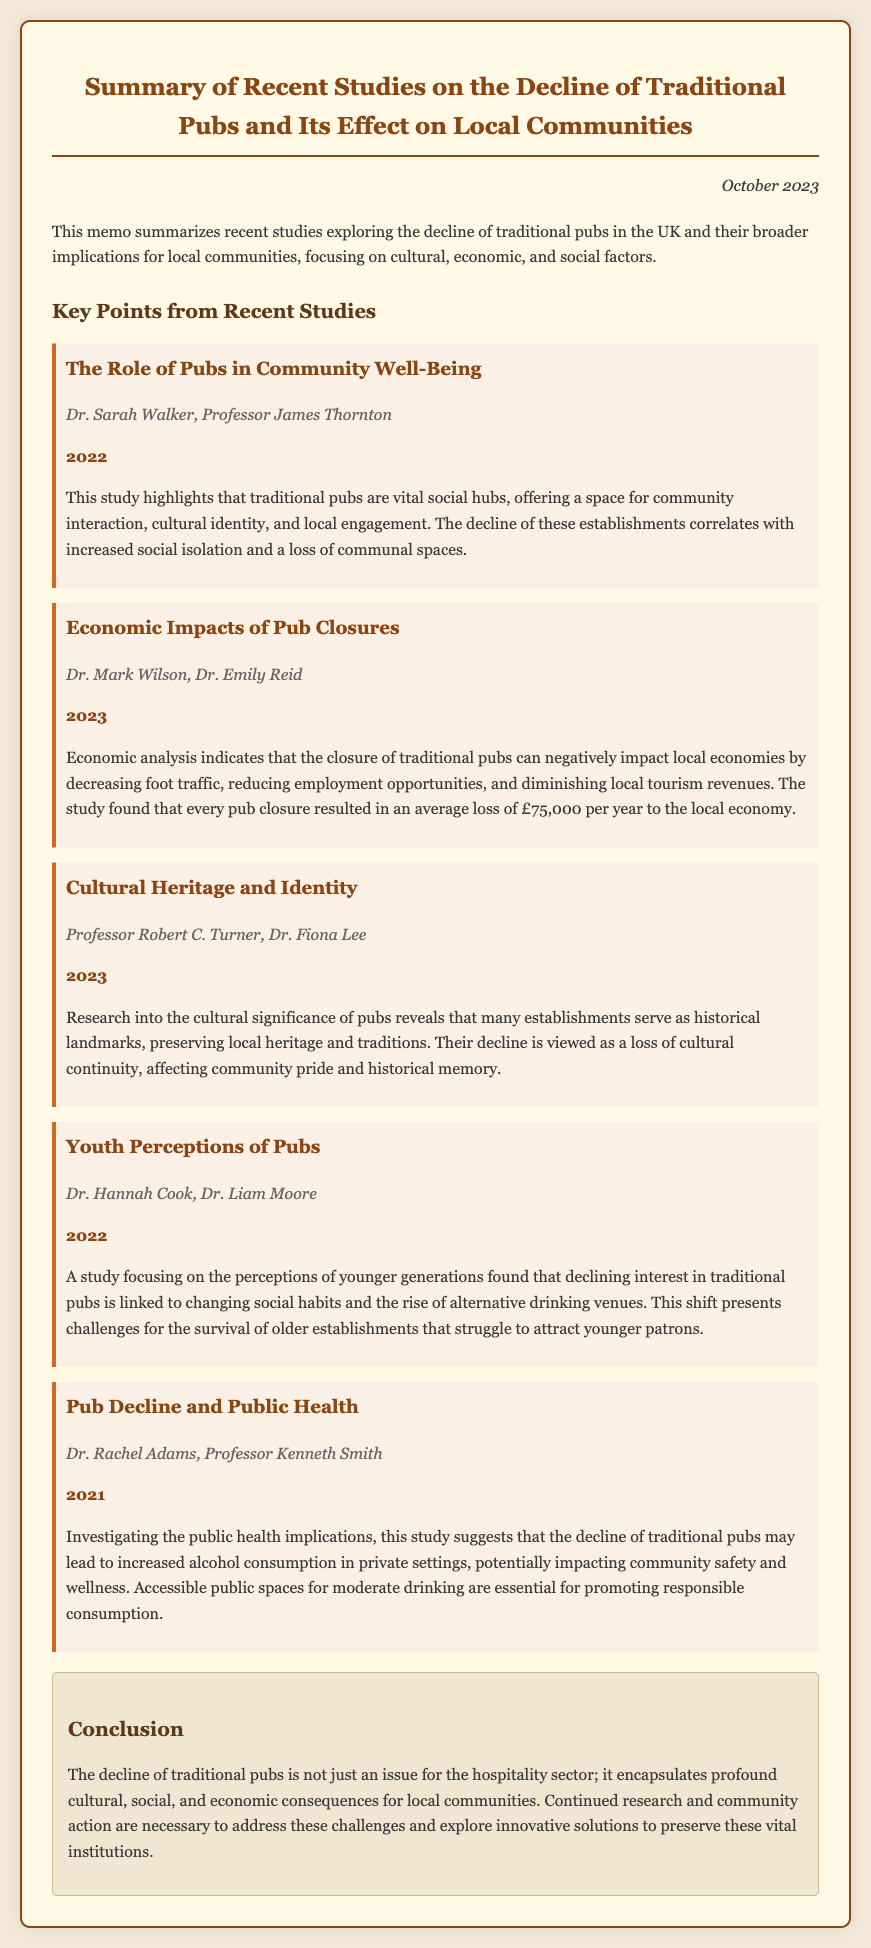What year was the study by Dr. Sarah Walker and Professor James Thornton published? This information can be found in the citation of the study within the memo, which states the publication year directly.
Answer: 2022 What is the average economic loss per year due to a pub closure? This figure is stated in the economic impacts study, highlighting the specific financial impact of pub closures on local economies.
Answer: £75,000 Who authored the study on cultural heritage and identity? The authorship information provided in the document indicates who conducted the research on the cultural significance of pubs.
Answer: Professor Robert C. Turner, Dr. Fiona Lee What is one reason for the decline of traditional pubs according to the youth perceptions study? This aspect relates to the findings of the study focusing on younger generations and their changing habits regarding social drinking spaces.
Answer: Changing social habits What major public health implication is associated with the decline of traditional pubs? The public health study outlines the connection between pub decline and its effects on alcohol consumption and community safety.
Answer: Increased alcohol consumption What do traditional pubs serve as, according to the cultural heritage study? This information underscores the role of pubs in preserving local traditions and forms part of the study's conclusions about their cultural significance.
Answer: Historical landmarks Which two researchers studied the economic impacts of pub closures? The memo clearly names both authors involved in researching the financial implications of traditional pubs' decline.
Answer: Dr. Mark Wilson, Dr. Emily Reid What is emphasized as essential for promoting responsible consumption in the public health study? This highlights the importance placed on specific types of public spaces in relation to healthy drinking behaviors.
Answer: Accessible public spaces 